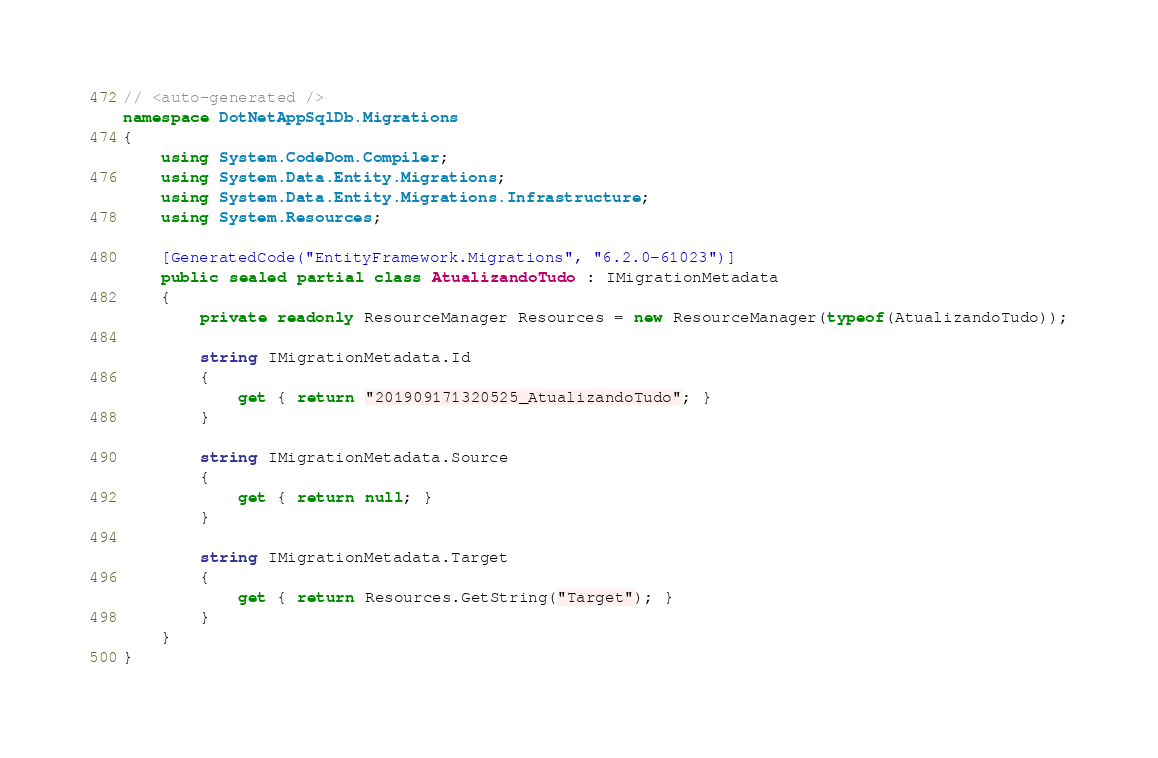Convert code to text. <code><loc_0><loc_0><loc_500><loc_500><_C#_>// <auto-generated />
namespace DotNetAppSqlDb.Migrations
{
    using System.CodeDom.Compiler;
    using System.Data.Entity.Migrations;
    using System.Data.Entity.Migrations.Infrastructure;
    using System.Resources;
    
    [GeneratedCode("EntityFramework.Migrations", "6.2.0-61023")]
    public sealed partial class AtualizandoTudo : IMigrationMetadata
    {
        private readonly ResourceManager Resources = new ResourceManager(typeof(AtualizandoTudo));
        
        string IMigrationMetadata.Id
        {
            get { return "201909171320525_AtualizandoTudo"; }
        }
        
        string IMigrationMetadata.Source
        {
            get { return null; }
        }
        
        string IMigrationMetadata.Target
        {
            get { return Resources.GetString("Target"); }
        }
    }
}
</code> 